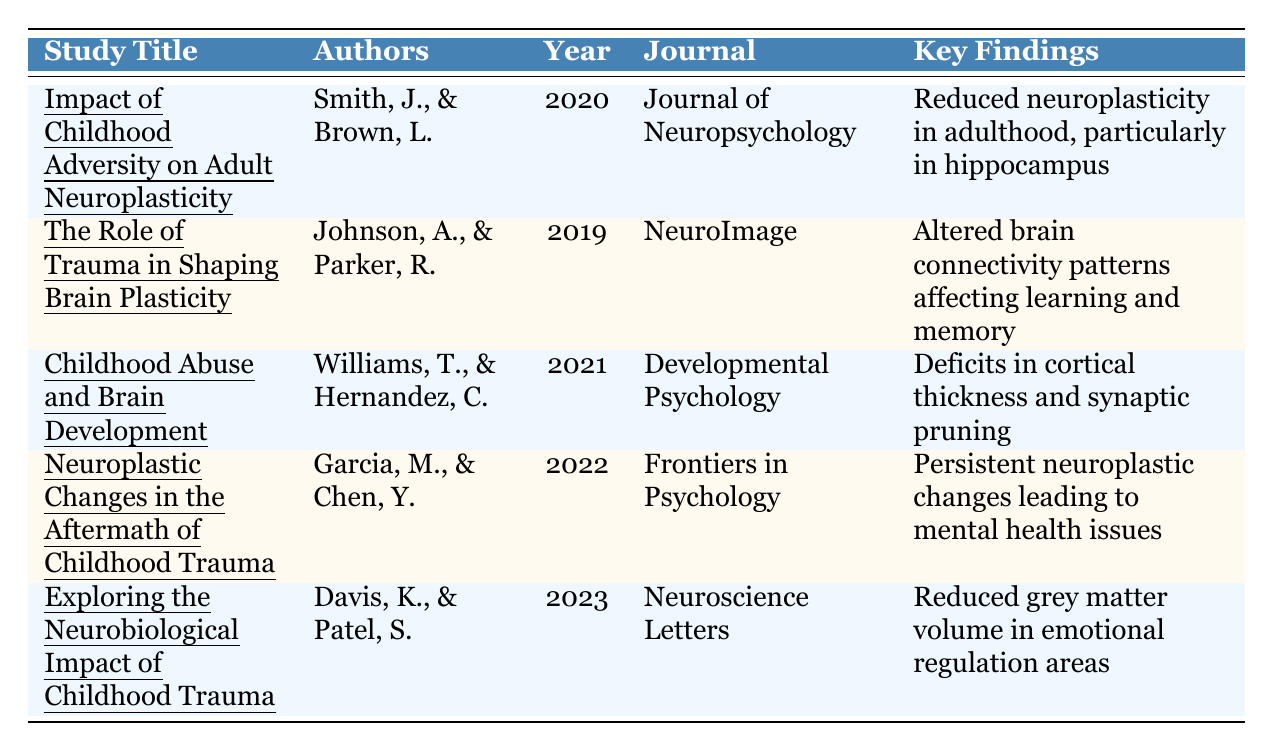What is the sample size of the study titled "Impact of Childhood Adversity on Adult Neuroplasticity"? The sample size is provided in the "Sample Size" column for each study. For this study, it indicates 250.
Answer: 250 Which study was published in 2021? By checking the "Published Year" column, the entries show that the study titled "Childhood Abuse and Brain Development" was published in 2021.
Answer: "Childhood Abuse and Brain Development" What are the key findings of the study authored by Davis and Patel? The table contains the "Key Findings" for each study. For the study by Davis and Patel, the key finding is that children with a history of trauma exhibited reduced grey matter volume in areas associated with emotional regulation.
Answer: Reduced grey matter volume in emotional regulation areas Which author is associated with the 2022 study? The "Authors" column lists the authors for each study. The study published in 2022 is authored by Garcia, M., and Chen, Y.
Answer: Garcia, M., and Chen, Y What was the average sample size across all studies? To find the average sample size, add all the sample sizes (250 + 150 + 400 + 320 + 200 = 1320) and divide by the number of studies (5). Thus, the average is 1320 / 5 = 264.
Answer: 264 Is it true that the study titled "Neuroplastic Changes in the Aftermath of Childhood Trauma" suggests a potential for resilience through therapeutic interventions? The "Notes" section for this study explicitly mentions potential resilience through therapeutic interventions, confirming that it is true.
Answer: Yes Which study has the largest sample size, and what is that size? By reviewing the "Sample Size" column, the study with the largest sample size is "Childhood Abuse and Brain Development" which has 400 participants.
Answer: "Childhood Abuse and Brain Development", 400 How many studies found reduced neuroplasticity or its effects? The studies "Impact of Childhood Adversity on Adult Neuroplasticity," "Neuroplastic Changes in the Aftermath of Childhood Trauma," and "Exploring the Neurobiological Impact of Childhood Trauma" discuss reduced neuroplasticity or its consequences. So, it’s a total of 3 studies.
Answer: 3 What was the focus area for Smith and Brown's study? The key findings state that the focus was on reduced neuroplasticity in adulthood, especially in the hippocampus.
Answer: Reduced neuroplasticity in the hippocampus Which journals published the studies with authors Johnson and Parker, and Garcia and Chen? The table lists "NeuroImage" for Johnson and Parker's study and "Frontiers in Psychology" for Garcia and Chen's study under the "Journal" column.
Answer: NeuroImage; Frontiers in Psychology What is the relationship between childhood trauma and neurodevelopmental outcomes according to Williams and Hernandez? Williams and Hernandez found significant deficits in cortical thickness and synaptic pruning among trauma-exposed children, indicating a direct link between childhood trauma and neurodevelopmental outcomes.
Answer: Significant deficits in cortical thickness and synaptic pruning 